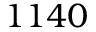<formula> <loc_0><loc_0><loc_500><loc_500>1 1 4 0</formula> 